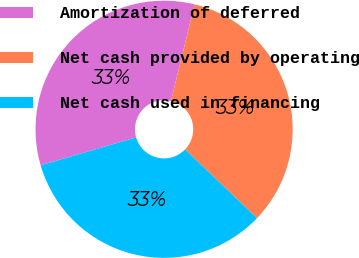Convert chart to OTSL. <chart><loc_0><loc_0><loc_500><loc_500><pie_chart><fcel>Amortization of deferred<fcel>Net cash provided by operating<fcel>Net cash used in financing<nl><fcel>33.33%<fcel>33.33%<fcel>33.33%<nl></chart> 